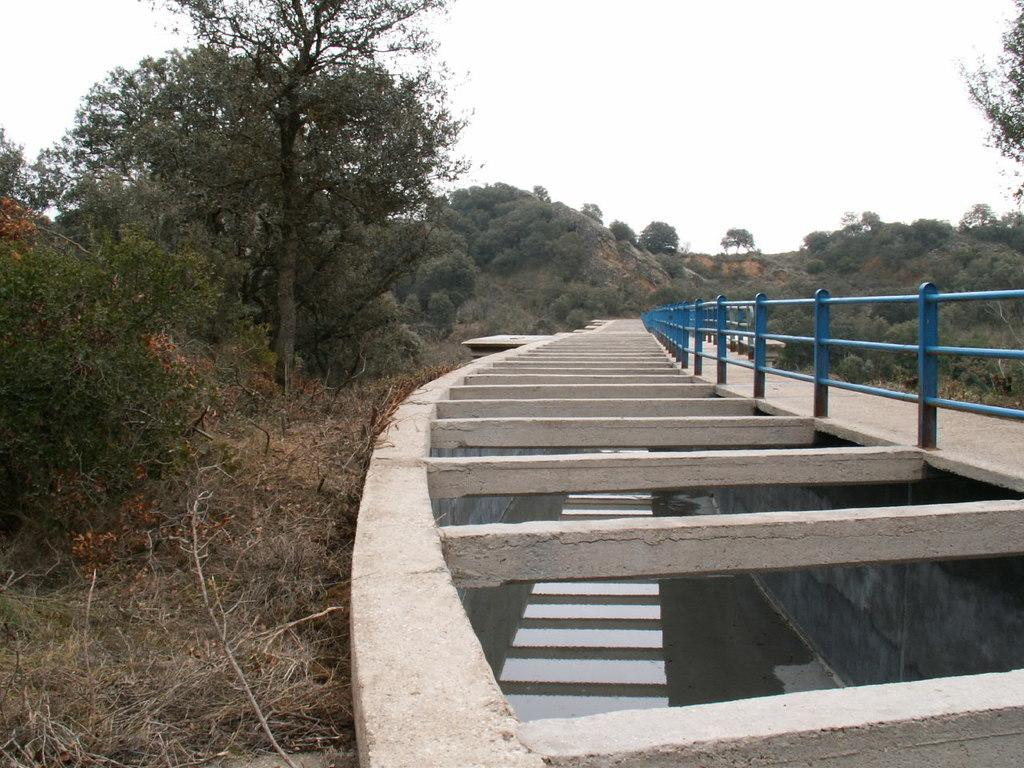What structure can be seen in the image? There is a bridge in the image. What feature does the bridge have? The bridge has railing. What natural element is visible in the image? There is water visible in the image. What type of vegetation can be seen in the image? There is grass in the image. What can be seen in the background of the image? There are trees, clouds, and the sky visible in the background of the image. What type of record is being played on the bridge in the image? There is no record player or record visible in the image; it only features a bridge with railing, water, grass, trees, clouds, and the sky. 